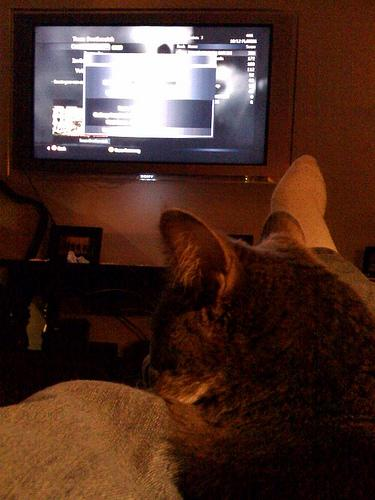What is the person doing in the bed?

Choices:
A) cleaning
B) sleeping
C) watching television
D) eating watching television 